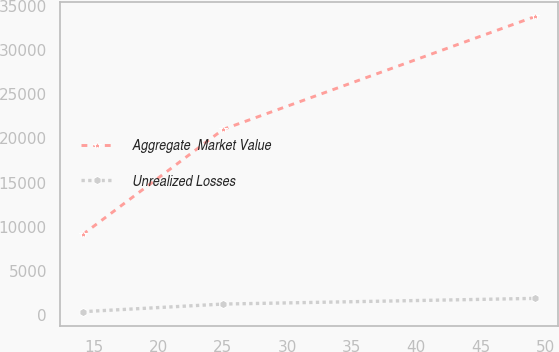<chart> <loc_0><loc_0><loc_500><loc_500><line_chart><ecel><fcel>Aggregate  Market Value<fcel>Unrealized Losses<nl><fcel>14.15<fcel>9118.21<fcel>373.43<nl><fcel>25.04<fcel>21026.5<fcel>1236.8<nl><fcel>49.22<fcel>33811.1<fcel>1879.68<nl></chart> 